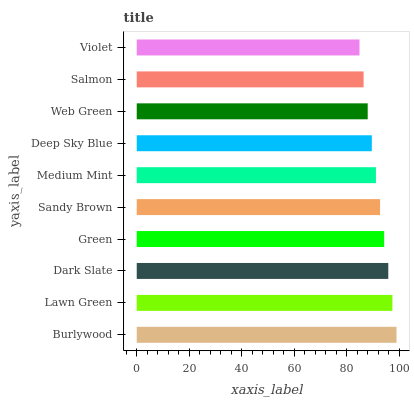Is Violet the minimum?
Answer yes or no. Yes. Is Burlywood the maximum?
Answer yes or no. Yes. Is Lawn Green the minimum?
Answer yes or no. No. Is Lawn Green the maximum?
Answer yes or no. No. Is Burlywood greater than Lawn Green?
Answer yes or no. Yes. Is Lawn Green less than Burlywood?
Answer yes or no. Yes. Is Lawn Green greater than Burlywood?
Answer yes or no. No. Is Burlywood less than Lawn Green?
Answer yes or no. No. Is Sandy Brown the high median?
Answer yes or no. Yes. Is Medium Mint the low median?
Answer yes or no. Yes. Is Green the high median?
Answer yes or no. No. Is Deep Sky Blue the low median?
Answer yes or no. No. 